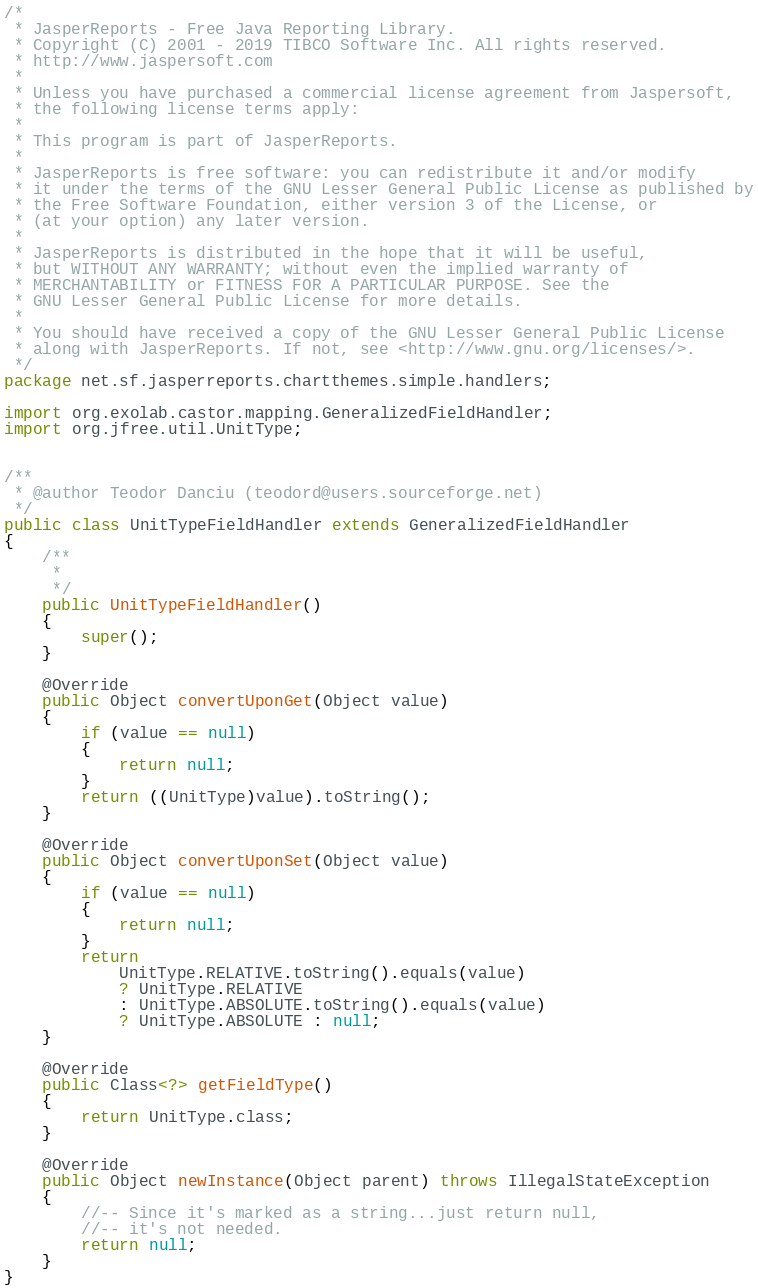<code> <loc_0><loc_0><loc_500><loc_500><_Java_>/*
 * JasperReports - Free Java Reporting Library.
 * Copyright (C) 2001 - 2019 TIBCO Software Inc. All rights reserved.
 * http://www.jaspersoft.com
 *
 * Unless you have purchased a commercial license agreement from Jaspersoft,
 * the following license terms apply:
 *
 * This program is part of JasperReports.
 *
 * JasperReports is free software: you can redistribute it and/or modify
 * it under the terms of the GNU Lesser General Public License as published by
 * the Free Software Foundation, either version 3 of the License, or
 * (at your option) any later version.
 *
 * JasperReports is distributed in the hope that it will be useful,
 * but WITHOUT ANY WARRANTY; without even the implied warranty of
 * MERCHANTABILITY or FITNESS FOR A PARTICULAR PURPOSE. See the
 * GNU Lesser General Public License for more details.
 *
 * You should have received a copy of the GNU Lesser General Public License
 * along with JasperReports. If not, see <http://www.gnu.org/licenses/>.
 */
package net.sf.jasperreports.chartthemes.simple.handlers;

import org.exolab.castor.mapping.GeneralizedFieldHandler;
import org.jfree.util.UnitType;


/**
 * @author Teodor Danciu (teodord@users.sourceforge.net)
 */
public class UnitTypeFieldHandler extends GeneralizedFieldHandler
{
	/**
	 *
	 */
	public UnitTypeFieldHandler()
	{
		super();
	}
	
	@Override
	public Object convertUponGet(Object value)
	{
		if (value == null)
		{
			return null;
		}
		return ((UnitType)value).toString();
	}

	@Override
	public Object convertUponSet(Object value)
	{
		if (value == null)
		{
			return null;
		}
		return 
			UnitType.RELATIVE.toString().equals(value) 
			? UnitType.RELATIVE 
			: UnitType.ABSOLUTE.toString().equals(value)
			? UnitType.ABSOLUTE : null;
	}
	
	@Override
	public Class<?> getFieldType()
	{
		return UnitType.class;
	}

	@Override
	public Object newInstance(Object parent) throws IllegalStateException
	{
		//-- Since it's marked as a string...just return null,
		//-- it's not needed.
		return null;
	}
}
</code> 